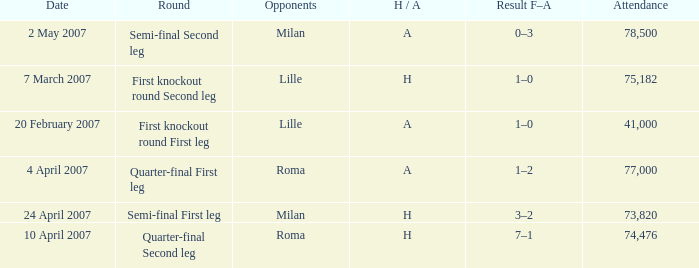Which round has Attendance larger than 41,000, a H/A of A, and a Result F–A of 1–2? Quarter-final First leg. 